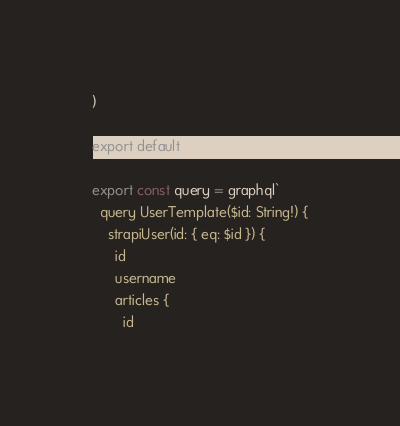<code> <loc_0><loc_0><loc_500><loc_500><_JavaScript_>)

export default UserTemplate

export const query = graphql`
  query UserTemplate($id: String!) {
    strapiUser(id: { eq: $id }) {
      id
      username
      articles {
        id</code> 